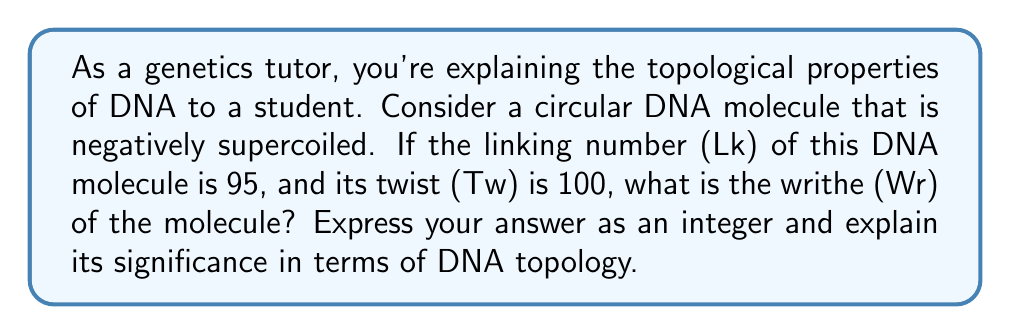Could you help me with this problem? To solve this problem, we need to understand the relationship between linking number (Lk), twist (Tw), and writhe (Wr) in DNA topology. These quantities are related by the fundamental equation:

$$ Lk = Tw + Wr $$

Here's a step-by-step explanation:

1) We are given that the linking number (Lk) is 95 and the twist (Tw) is 100.

2) Substituting these values into the equation:

   $$ 95 = 100 + Wr $$

3) To solve for Wr, we subtract 100 from both sides:

   $$ Wr = 95 - 100 = -5 $$

4) The negative value of writhe (-5) indicates that the DNA is negatively supercoiled, which is consistent with the information given in the question.

5) In DNA topology, writhe represents the three-dimensional path of the DNA axis in space. A negative writhe indicates that the DNA helix axis winds around itself in a left-handed manner.

6) The magnitude of writhe (5 in this case) represents the degree of supercoiling. A higher absolute value would indicate more severe supercoiling.

7) This supercoiling is important in DNA compaction and can affect various cellular processes, including DNA replication and transcription.
Answer: $$ Wr = -5 $$
The writhe of the circular DNA molecule is -5, indicating negative supercoiling. 